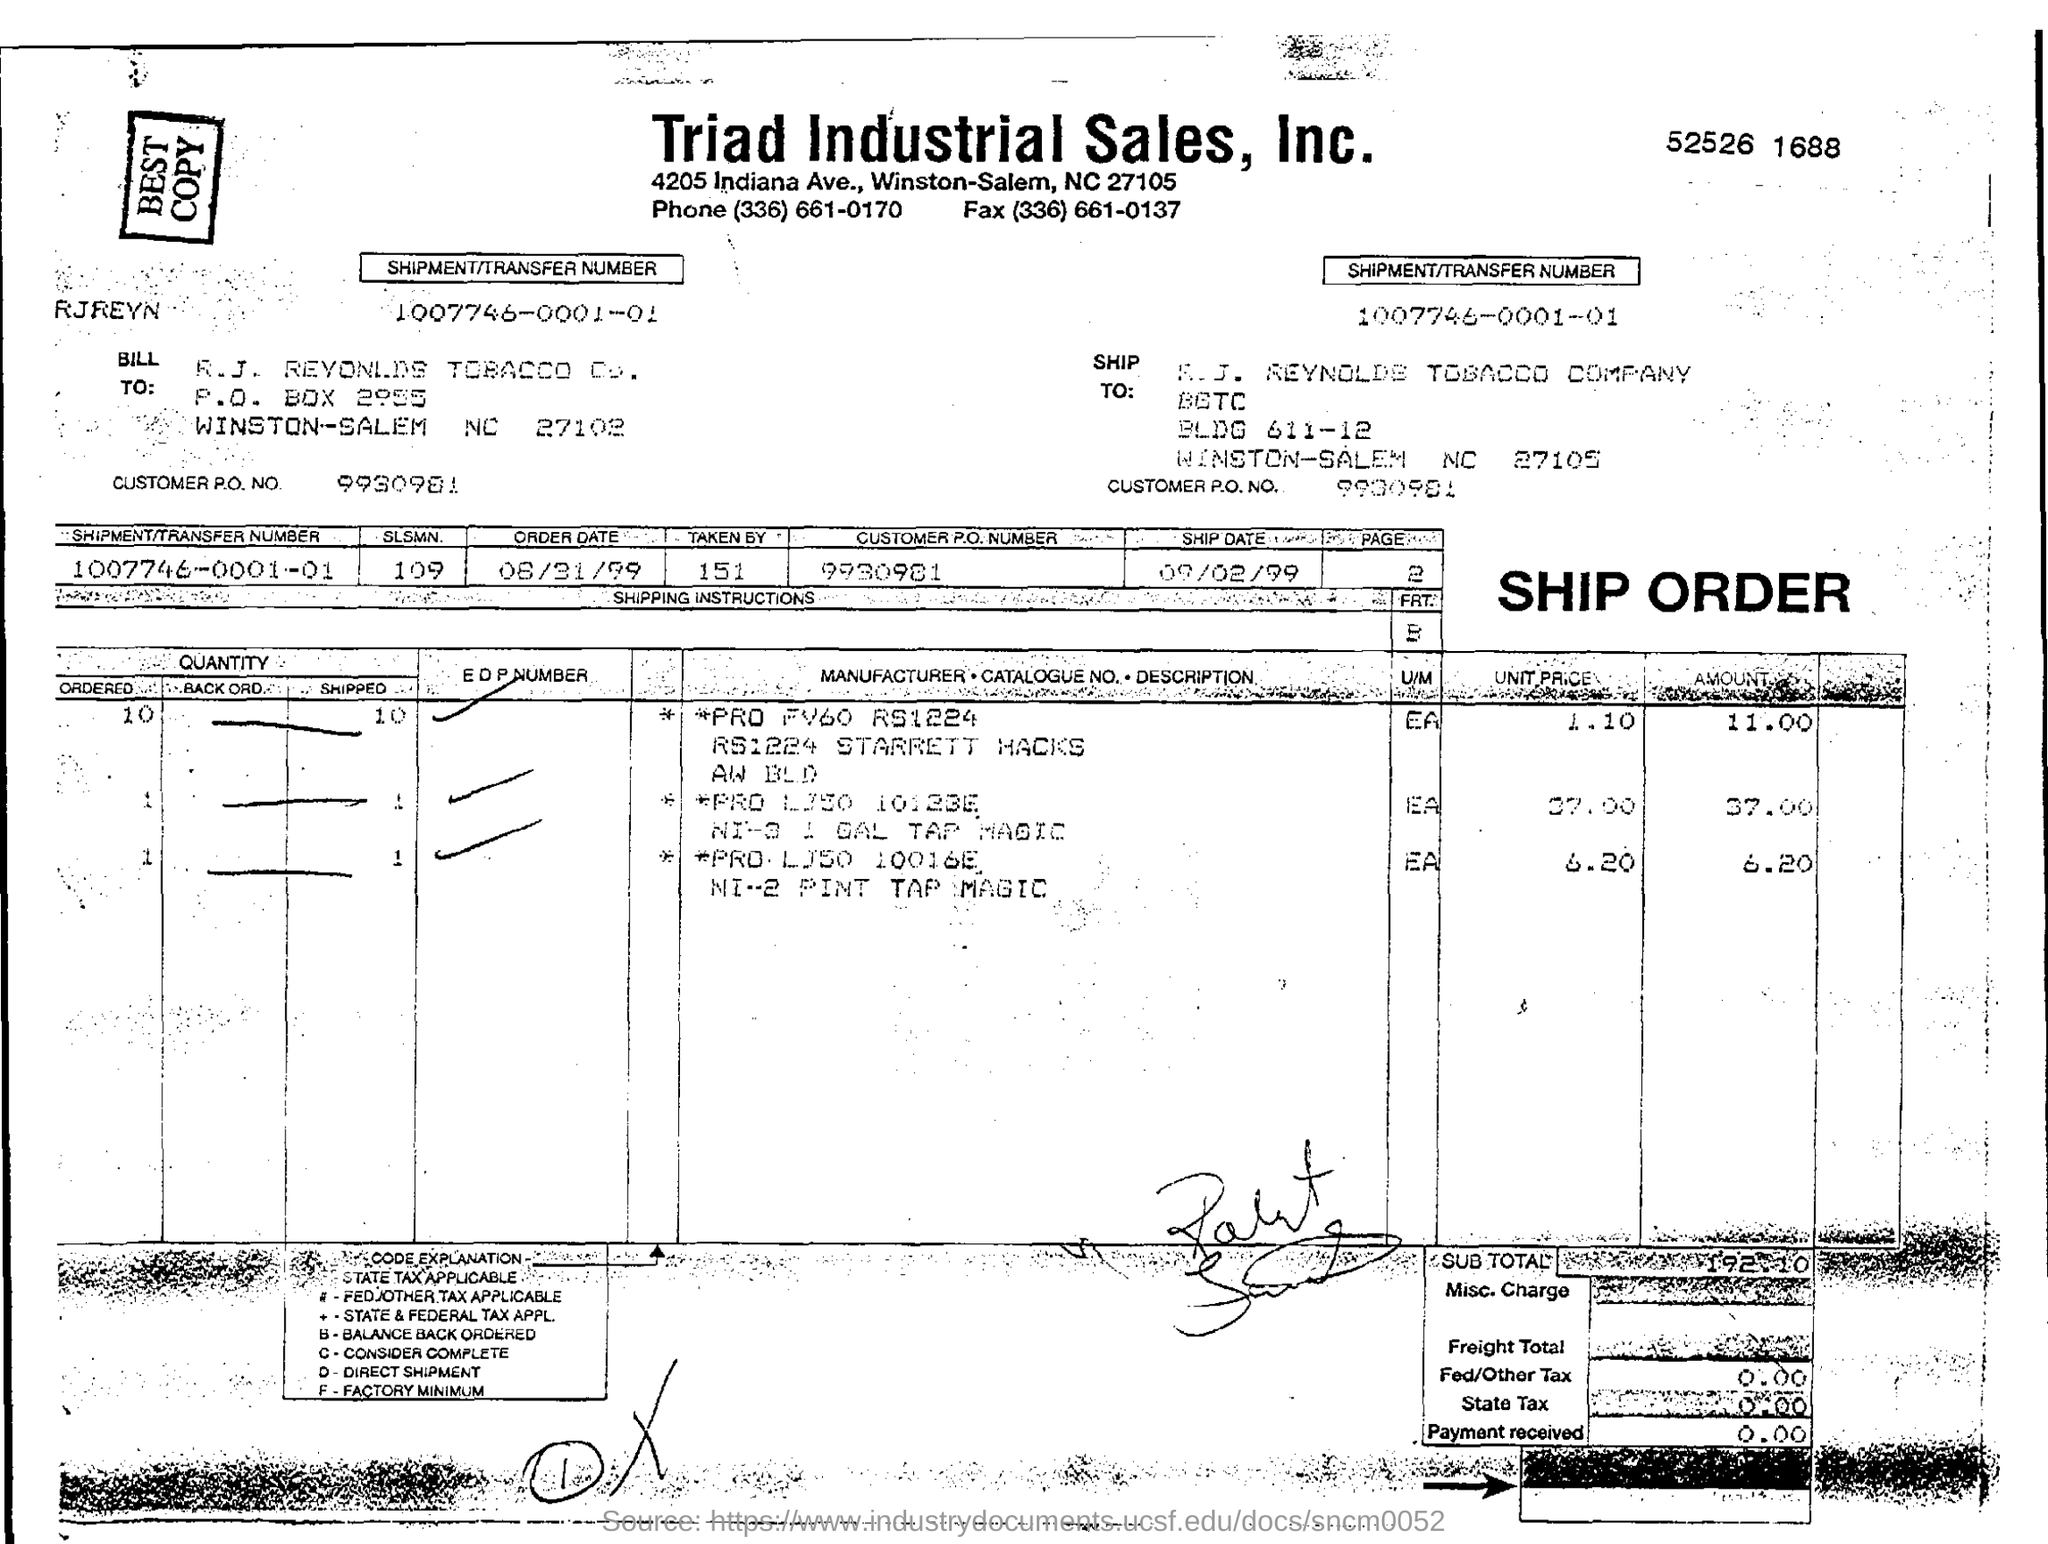Mention a couple of crucial points in this snapshot. Please provide the shipment/transfer number for the order 1007746-0001-01... What is the ship date? 09/02/99. The order date is August 31, 1999. The shipment in question is being sent to R.J. Reynolds Tobacco Company. Please provide the customer purchase order number 9930981... 